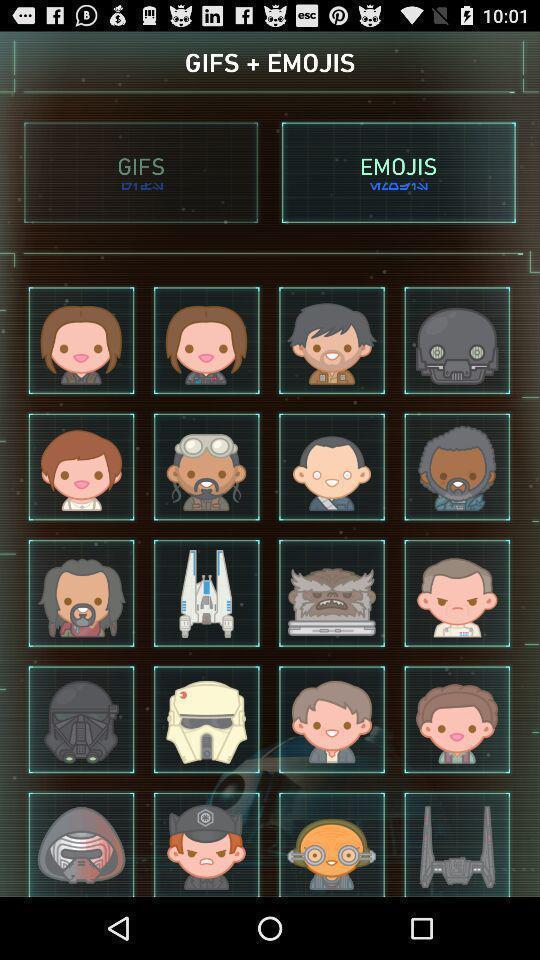Summarize the main components in this picture. Page displaying with different emotions. 